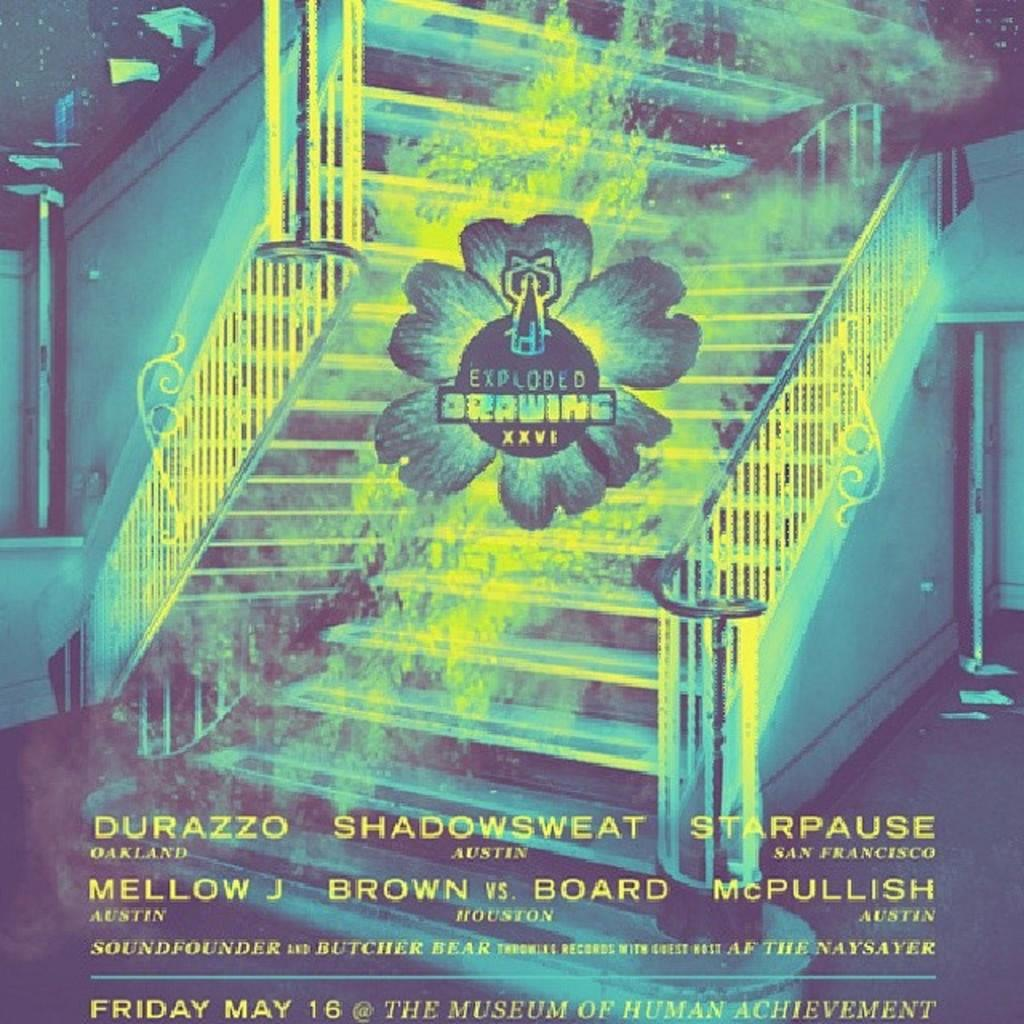What is featured in the picture? There is a poster in the picture. What can be found at the bottom of the poster? The poster has text at the bottom. What architectural feature is present in the picture? There are stairs in the picture. What is located in the middle of the picture? There is a logo in the middle of the picture. What is associated with the logo? The logo has text associated with it. Can you see any crayons being used to draw on the elbow in the picture? There is no mention of crayons or elbows in the provided facts, so we cannot answer this question based on the image. 